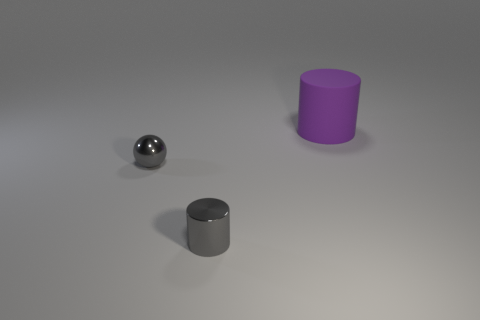Subtract 1 cylinders. How many cylinders are left? 1 Subtract all gray cylinders. How many cylinders are left? 1 Add 2 tiny yellow matte things. How many objects exist? 5 Subtract all cylinders. How many objects are left? 1 Subtract all red matte cylinders. Subtract all shiny objects. How many objects are left? 1 Add 2 matte cylinders. How many matte cylinders are left? 3 Add 3 small gray metallic balls. How many small gray metallic balls exist? 4 Subtract 1 gray spheres. How many objects are left? 2 Subtract all green spheres. Subtract all brown cylinders. How many spheres are left? 1 Subtract all purple balls. How many gray cylinders are left? 1 